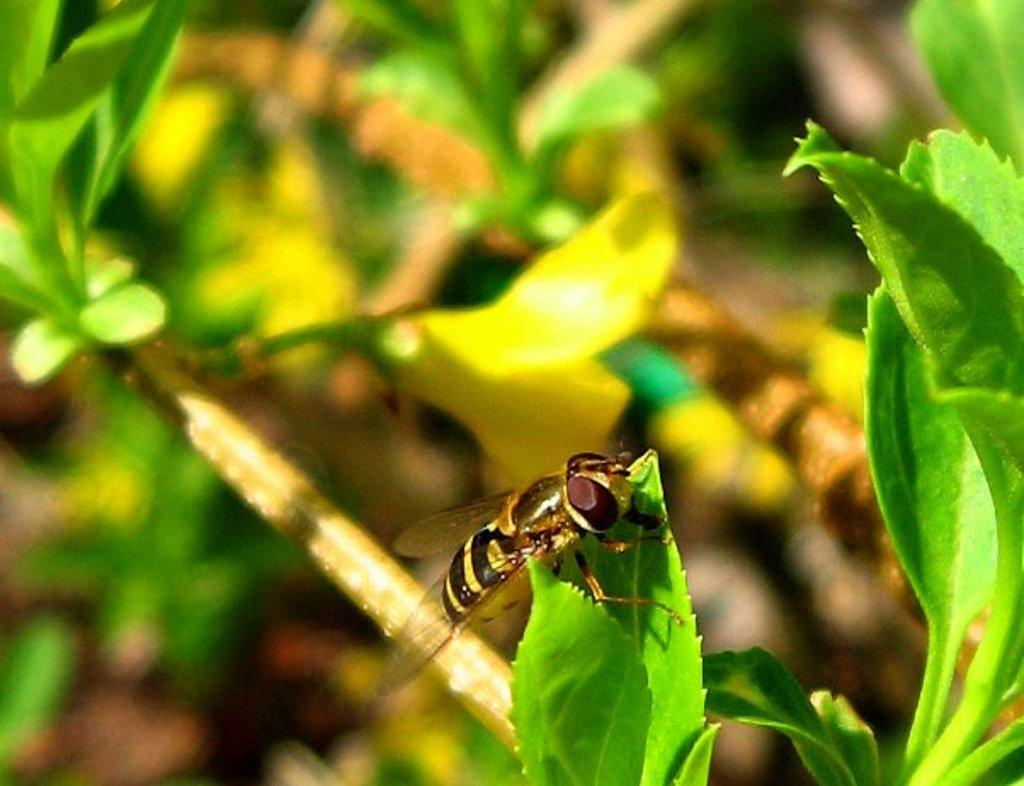What is on the leaf in the image? There is a fly on a leaf in the image. What can be seen behind the fly? There are leaves and branches visible behind the fly. What type of rail can be seen in the image? There is no rail present in the image; it features a fly on a leaf with leaves and branches in the background. 